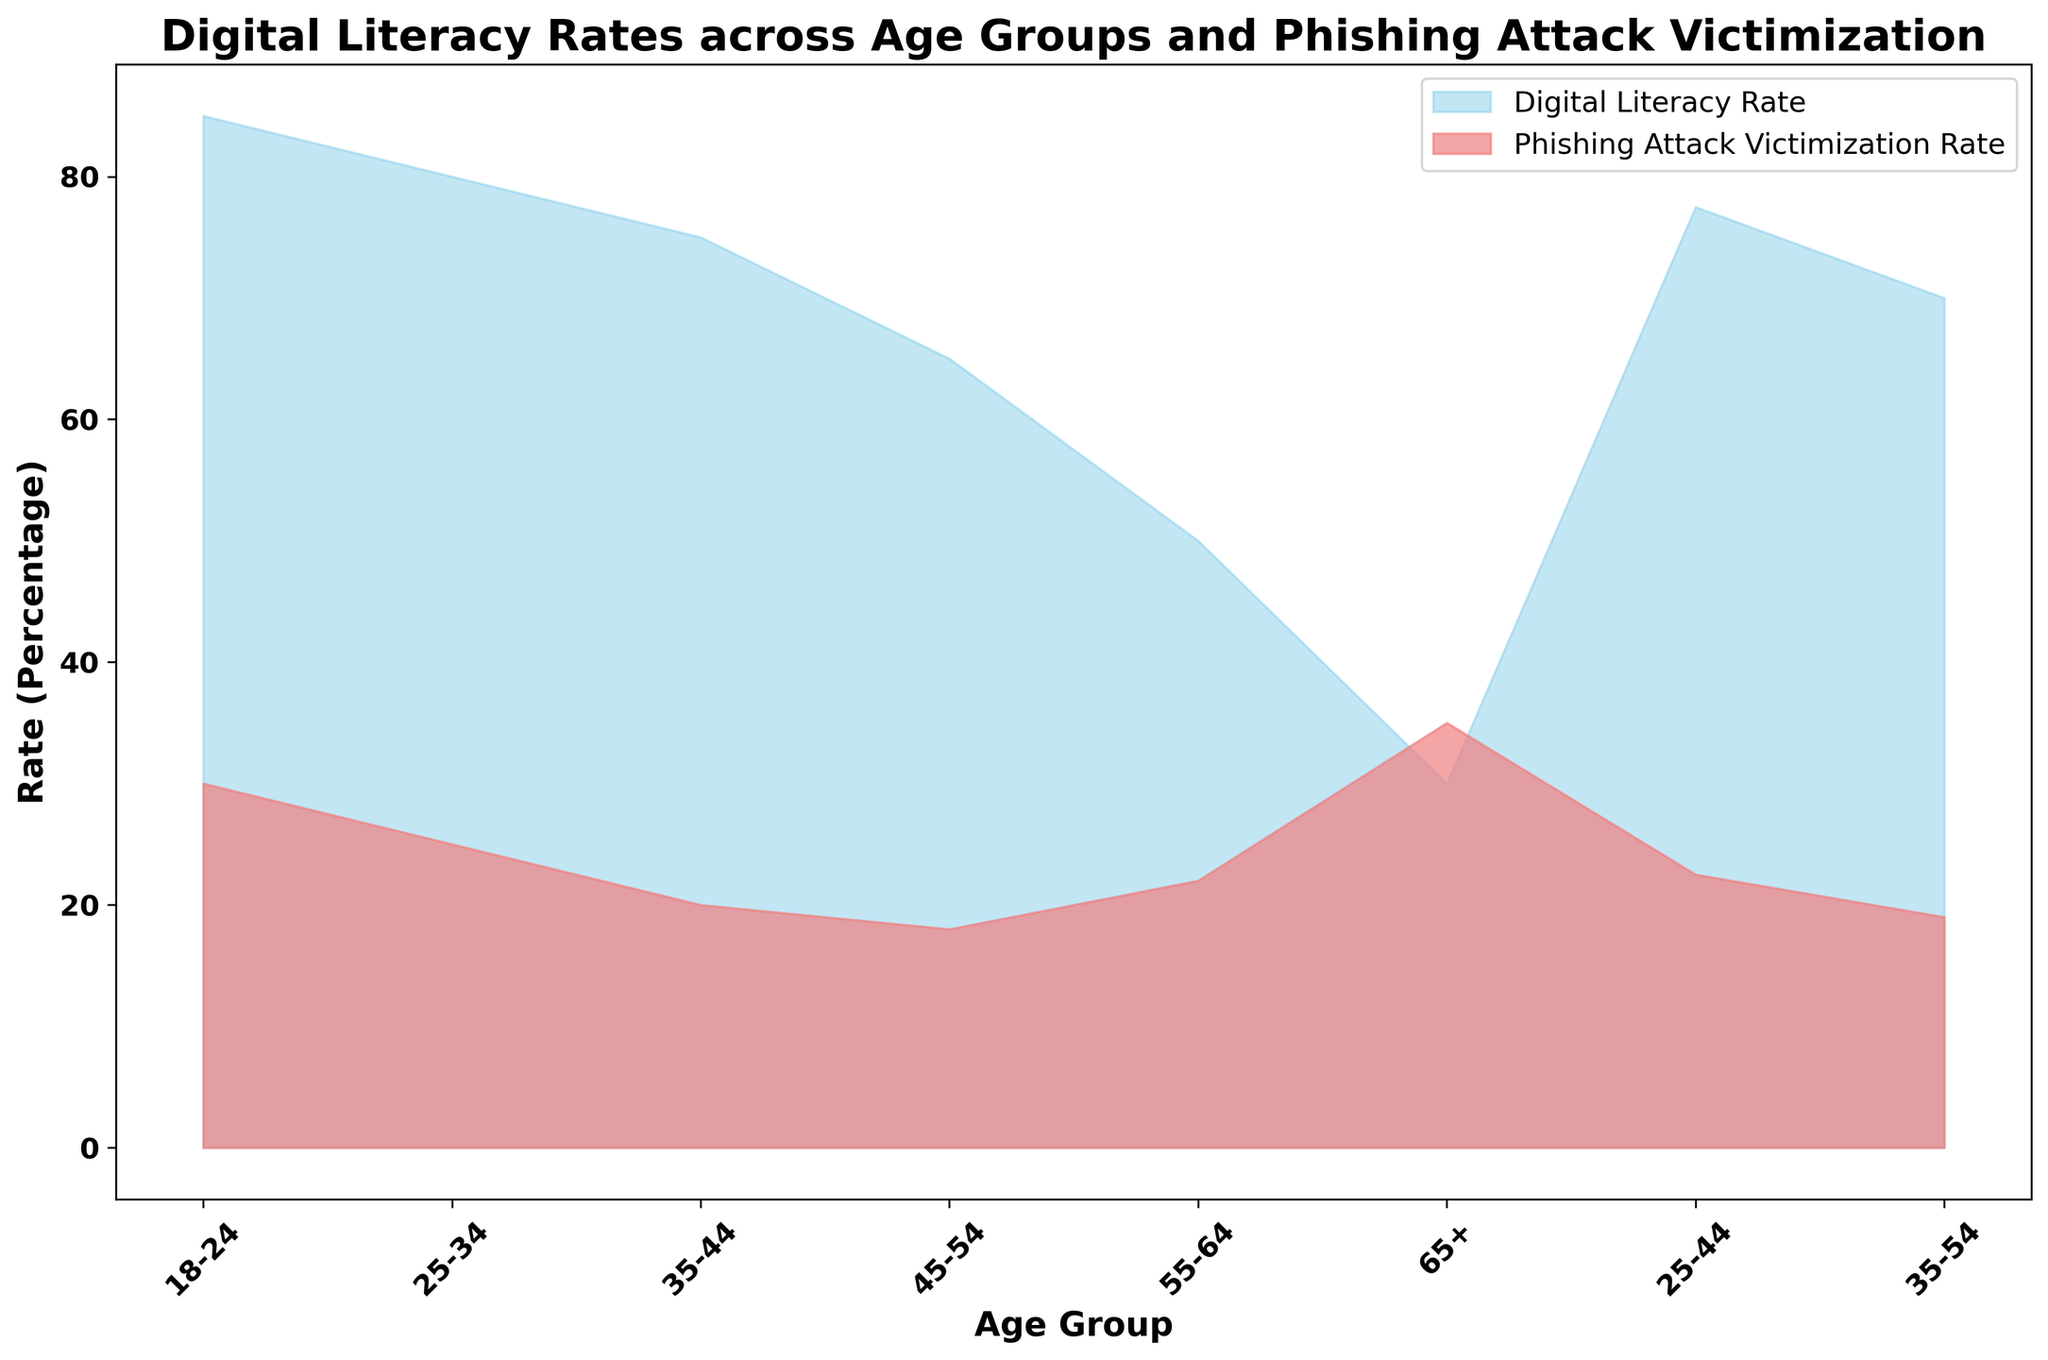Which age group has the highest digital literacy rate? By looking at the height of the blue area in the figure, the age group 18-24 stands out as having the highest digital literacy rate.
Answer: 18-24 Which age group has the highest phishing attack victimization rate? The highest phishing attack victimization rate can be identified by observing the tallest section of the red area in the chart, which corresponds to the age group 65+.
Answer: 65+ What is the difference in digital literacy rate between the 18-24 and 65+ age groups? The digital literacy rate for 18-24 is 85%, and for 65+ it is 30%. The difference is calculated as 85% - 30% = 55%.
Answer: 55% Compare the digital literacy rate and phishing attack victimization rate for the age group 55-64. Which is higher? The digital literacy rate for the age group 55-64 is 50%, and the phishing attack victimization rate is 22%. 50% is higher than 22%.
Answer: Digital Literacy Rate Is there an inverse relationship between digital literacy rates and phishing attack victimization rates across the age groups? By observing the chart, as the blue area (Digital Literacy Rate) decreases, the red area (Phishing Attack Victimization Rate) tends to increase, indicating an inverse relationship.
Answer: Yes What is the average digital literacy rate for the age groups 25-34, 35-44, and 45-54? The digital literacy rates for these age groups are 80%, 75%, and 65% respectively. The average is calculated as (80% + 75% + 65%) / 3 = 73.33%.
Answer: 73.33% Which age group has the closest digital literacy rate to the overall mean for the groups provided? Calculating the mean for the specified age groups: (85 + 80 + 75 + 65 + 50 + 30) / 6 = 63.33%. The age group 45-54, with a rate of 65%, is closest to this mean.
Answer: 45-54 What is the trend of phishing attack victimization rates as age increases? By following the red area from left to right, the trend shows that phishing attack victimization rates generally increase as age increases.
Answer: Increase Do any age groups have almost the same digital literacy rate as their phishing attack victimization rate? Observing the chart, there aren't any age groups where the digital literacy rate and phishing attack victimization rate are almost the same; they are always distinct.
Answer: No For the age group 35-44, how does the phishing attack victimization rate compare to the 45-54 group? The phishing attack victimization rate for 35-44 is 20%, whereas for 45-54 it is 18%. 20% is slightly higher than 18%.
Answer: 35-44 has a higher rate 